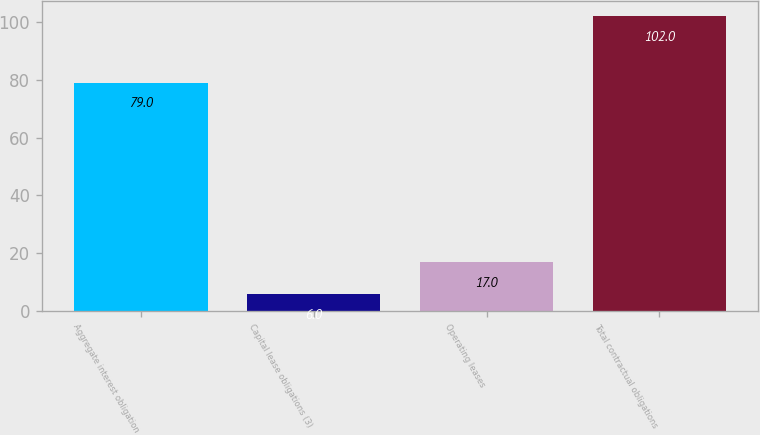Convert chart to OTSL. <chart><loc_0><loc_0><loc_500><loc_500><bar_chart><fcel>Aggregate interest obligation<fcel>Capital lease obligations (3)<fcel>Operating leases<fcel>Total contractual obligations<nl><fcel>79<fcel>6<fcel>17<fcel>102<nl></chart> 